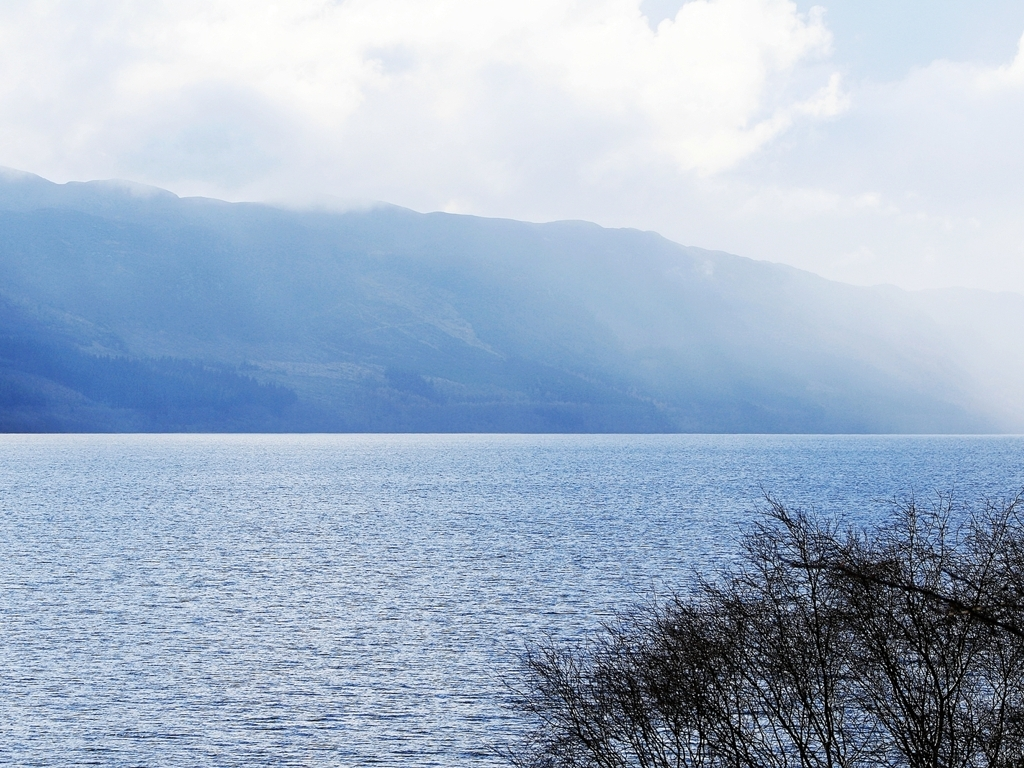What time of day does this image appear to be taken? The lighting in this image suggests it was likely taken in the mid-morning. The sky is bright and the lack of long shadows indicates the sun is higher in the sky. However, the exact time can't be precisely determined without more contextual information. If I were to visit this location, what would be the ideal activities to engage in? Visiting this lakeside location would be ideal for numerous outdoor activities. You could enjoy hiking or mountain biking in the surrounding mountains, participate in water sports like kayaking or paddle boarding on the lake, or simply have a peaceful picnic along the shore while enjoying the view. The calm atmosphere also makes it perfect for photography enthusiasts looking to capture natural beauty. 